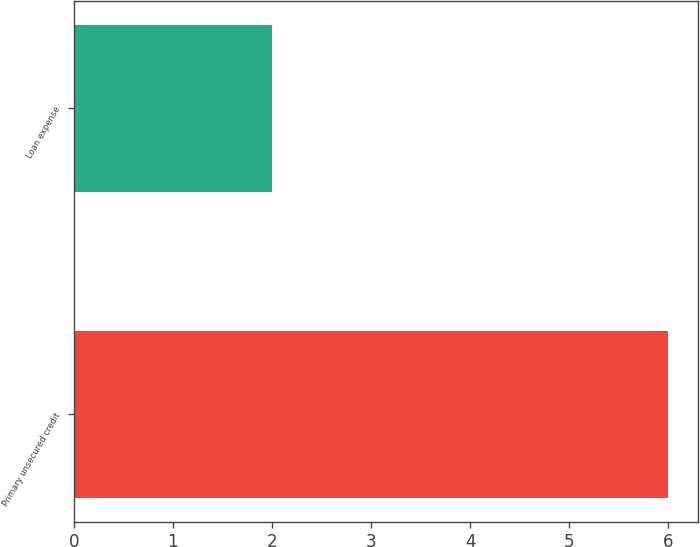<chart> <loc_0><loc_0><loc_500><loc_500><bar_chart><fcel>Primary unsecured credit<fcel>Loan expense<nl><fcel>6<fcel>2<nl></chart> 